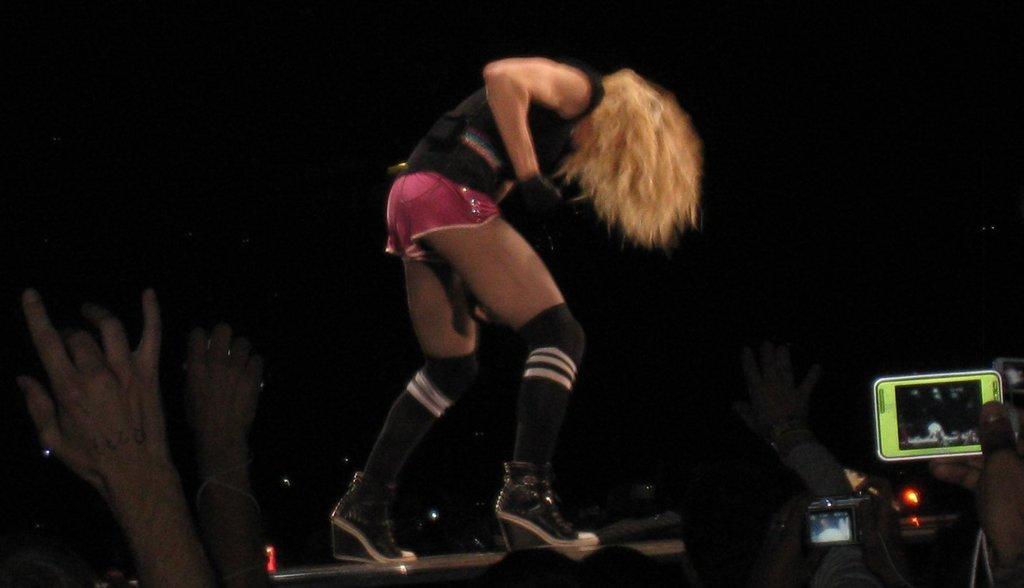Please provide a concise description of this image. In this image, we can see people hands. There is a person in the middle of the image wearing clothes. There is a camera and mobile in the bottom right of the image. 